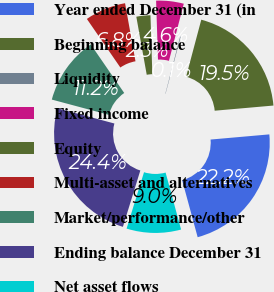Convert chart to OTSL. <chart><loc_0><loc_0><loc_500><loc_500><pie_chart><fcel>Year ended December 31 (in<fcel>Beginning balance<fcel>Liquidity<fcel>Fixed income<fcel>Equity<fcel>Multi-asset and alternatives<fcel>Market/performance/other<fcel>Ending balance December 31<fcel>Net asset flows<nl><fcel>22.17%<fcel>19.46%<fcel>0.1%<fcel>4.55%<fcel>2.32%<fcel>6.78%<fcel>11.23%<fcel>24.39%<fcel>9.0%<nl></chart> 